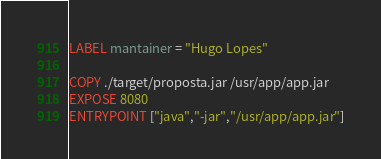Convert code to text. <code><loc_0><loc_0><loc_500><loc_500><_Dockerfile_>LABEL mantainer = "Hugo Lopes"

COPY ./target/proposta.jar /usr/app/app.jar
EXPOSE 8080
ENTRYPOINT ["java","-jar","/usr/app/app.jar"]
</code> 